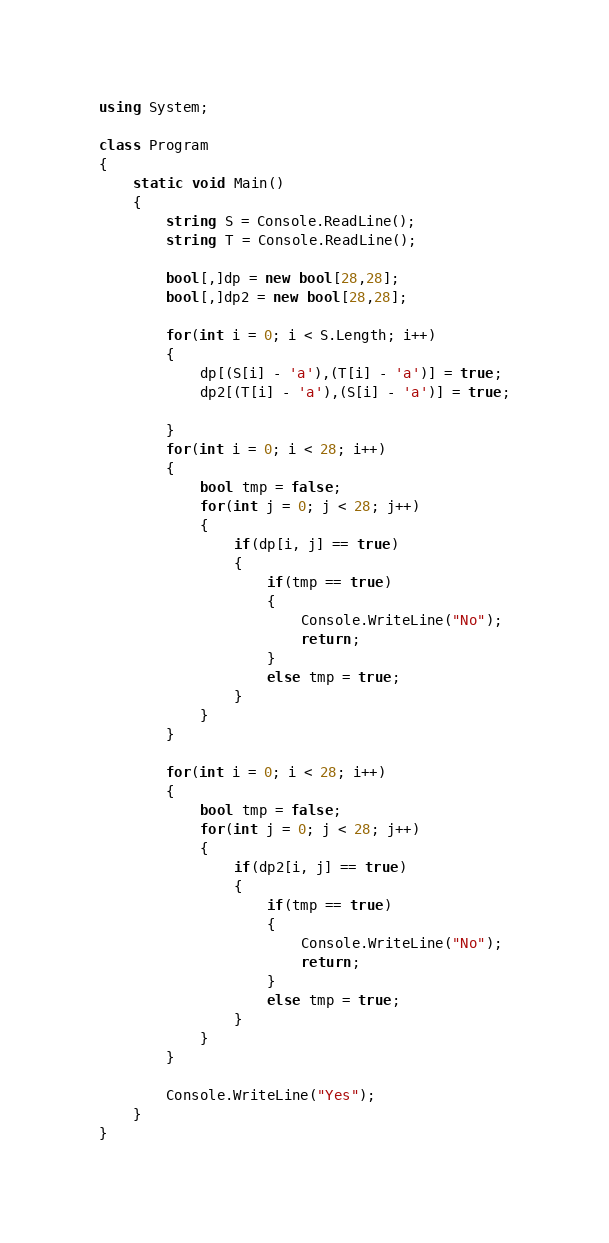<code> <loc_0><loc_0><loc_500><loc_500><_C#_>using System;

class Program
{	
	static void Main()
	{
		string S = Console.ReadLine();
		string T = Console.ReadLine();
		
		bool[,]dp = new bool[28,28];
		bool[,]dp2 = new bool[28,28];
		
		for(int i = 0; i < S.Length; i++)
		{
			dp[(S[i] - 'a'),(T[i] - 'a')] = true;
			dp2[(T[i] - 'a'),(S[i] - 'a')] = true;
		
		}
		for(int i = 0; i < 28; i++)
		{
			bool tmp = false;
			for(int j = 0; j < 28; j++)
			{
				if(dp[i, j] == true)
				{
					if(tmp == true)
					{
						Console.WriteLine("No");
						return;
					}
					else tmp = true;
				}
			}
		}
		
		for(int i = 0; i < 28; i++)
		{
			bool tmp = false;
			for(int j = 0; j < 28; j++)
			{
				if(dp2[i, j] == true)
				{
					if(tmp == true)
					{
						Console.WriteLine("No");
						return;
					}
					else tmp = true;
				}
			}
		}
		
		Console.WriteLine("Yes");
	}
}</code> 